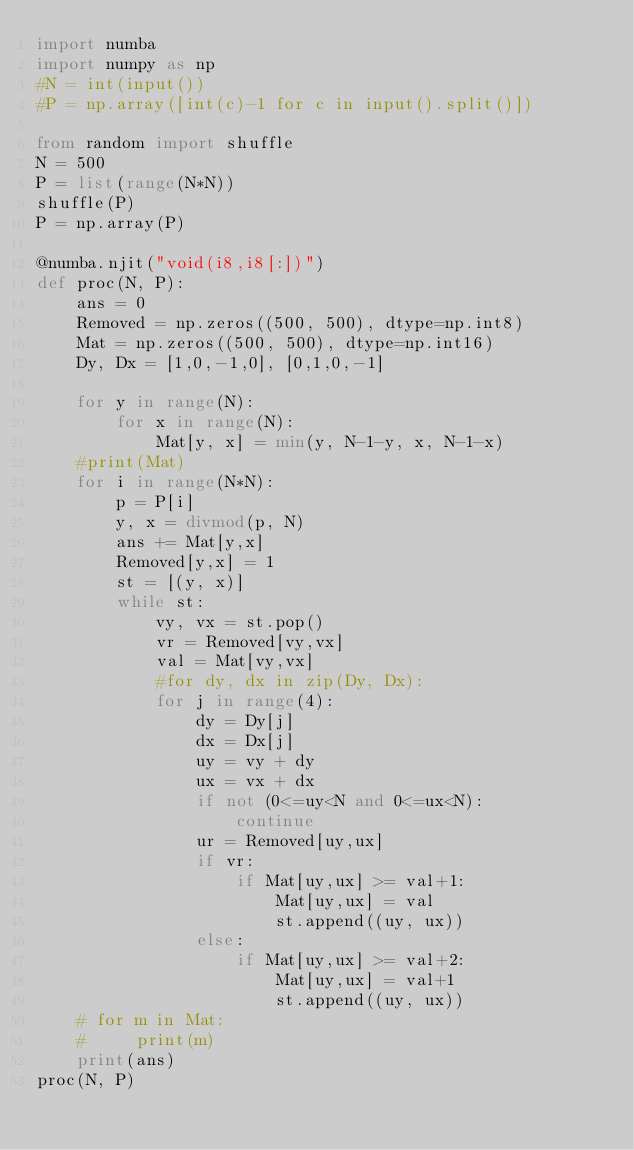Convert code to text. <code><loc_0><loc_0><loc_500><loc_500><_Python_>import numba
import numpy as np
#N = int(input())
#P = np.array([int(c)-1 for c in input().split()])

from random import shuffle
N = 500
P = list(range(N*N))
shuffle(P)
P = np.array(P)

@numba.njit("void(i8,i8[:])")
def proc(N, P):
    ans = 0
    Removed = np.zeros((500, 500), dtype=np.int8)
    Mat = np.zeros((500, 500), dtype=np.int16)
    Dy, Dx = [1,0,-1,0], [0,1,0,-1]

    for y in range(N):
        for x in range(N):
            Mat[y, x] = min(y, N-1-y, x, N-1-x)
    #print(Mat)
    for i in range(N*N):
        p = P[i]
        y, x = divmod(p, N)
        ans += Mat[y,x]
        Removed[y,x] = 1
        st = [(y, x)]
        while st:
            vy, vx = st.pop()
            vr = Removed[vy,vx]
            val = Mat[vy,vx]
            #for dy, dx in zip(Dy, Dx):
            for j in range(4):
                dy = Dy[j]
                dx = Dx[j]
                uy = vy + dy
                ux = vx + dx
                if not (0<=uy<N and 0<=ux<N):
                    continue
                ur = Removed[uy,ux]
                if vr:
                    if Mat[uy,ux] >= val+1:
                        Mat[uy,ux] = val
                        st.append((uy, ux))
                else:
                    if Mat[uy,ux] >= val+2:
                        Mat[uy,ux] = val+1
                        st.append((uy, ux))
    # for m in Mat:
    #     print(m)
    print(ans)
proc(N, P)

</code> 